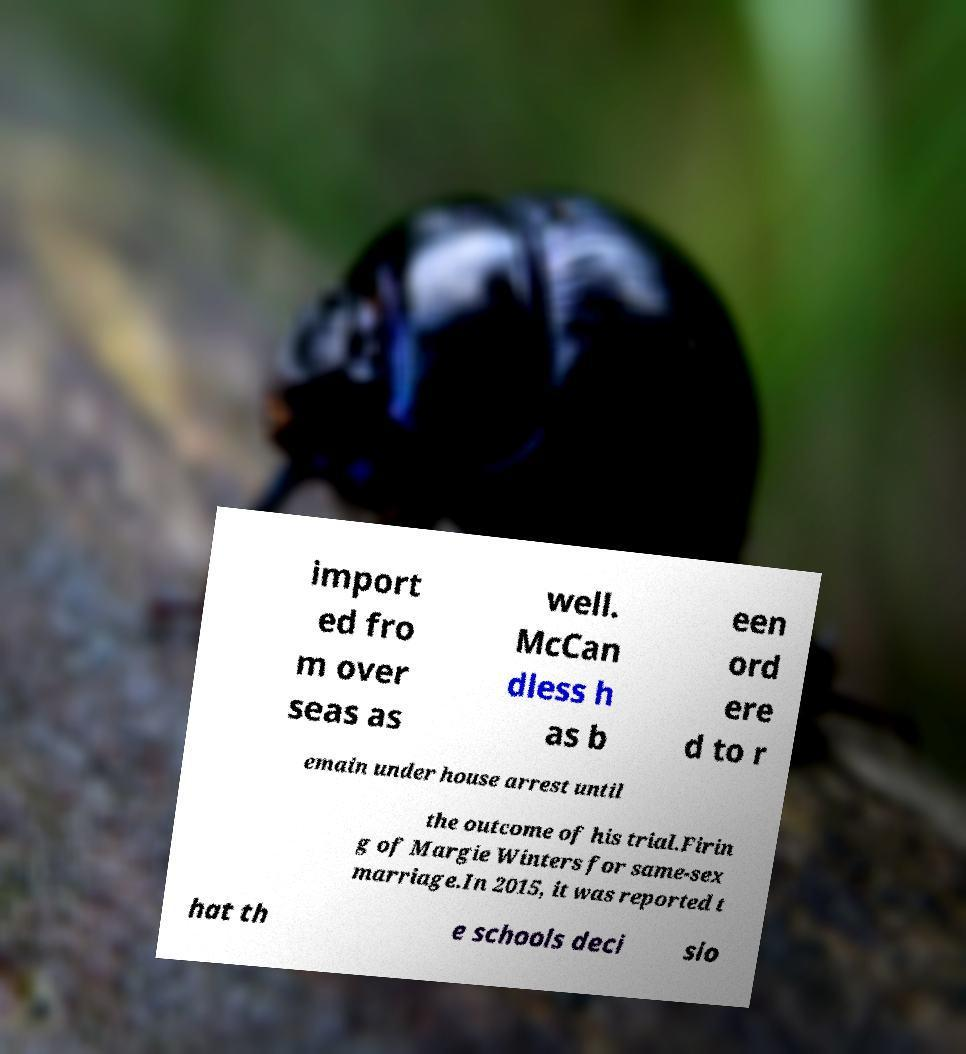I need the written content from this picture converted into text. Can you do that? import ed fro m over seas as well. McCan dless h as b een ord ere d to r emain under house arrest until the outcome of his trial.Firin g of Margie Winters for same-sex marriage.In 2015, it was reported t hat th e schools deci sio 